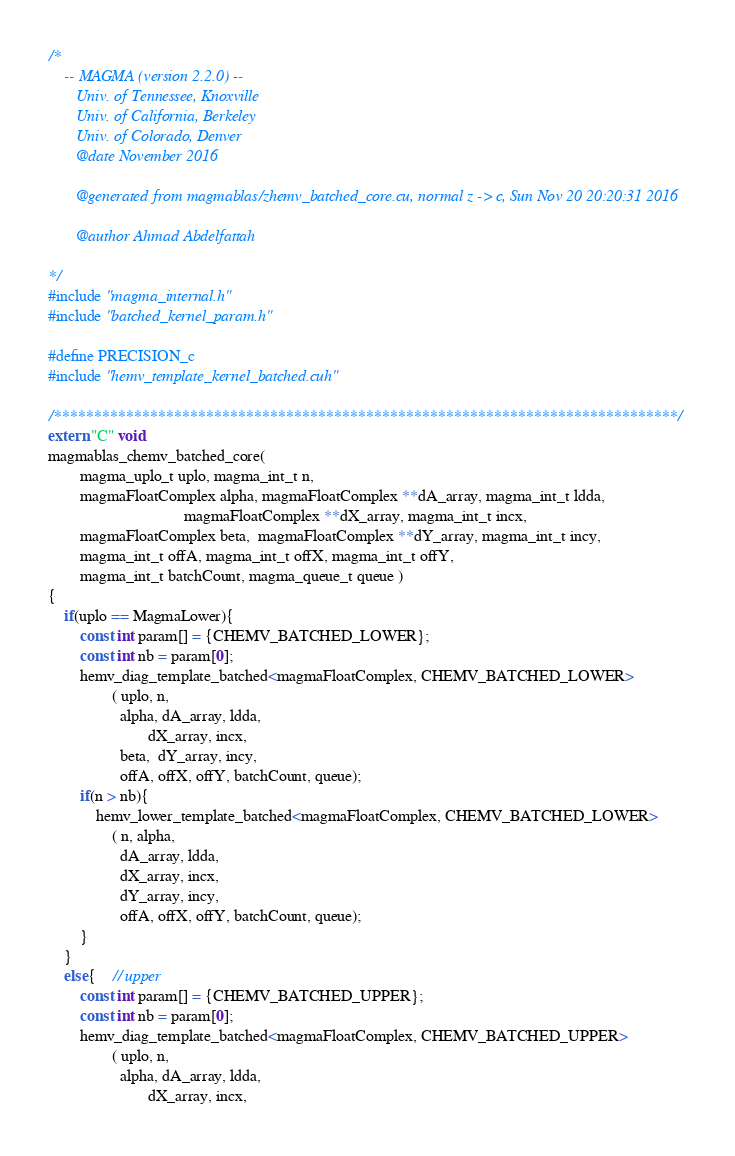Convert code to text. <code><loc_0><loc_0><loc_500><loc_500><_Cuda_>/*
    -- MAGMA (version 2.2.0) --
       Univ. of Tennessee, Knoxville
       Univ. of California, Berkeley
       Univ. of Colorado, Denver
       @date November 2016

       @generated from magmablas/zhemv_batched_core.cu, normal z -> c, Sun Nov 20 20:20:31 2016

       @author Ahmad Abdelfattah
       
*/
#include "magma_internal.h"
#include "batched_kernel_param.h"

#define PRECISION_c
#include "hemv_template_kernel_batched.cuh"

/******************************************************************************/
extern "C" void 
magmablas_chemv_batched_core(
        magma_uplo_t uplo, magma_int_t n, 
        magmaFloatComplex alpha, magmaFloatComplex **dA_array, magma_int_t ldda,
                                  magmaFloatComplex **dX_array, magma_int_t incx,
        magmaFloatComplex beta,  magmaFloatComplex **dY_array, magma_int_t incy,
        magma_int_t offA, magma_int_t offX, magma_int_t offY, 
        magma_int_t batchCount, magma_queue_t queue )
{
    if(uplo == MagmaLower){
        const int param[] = {CHEMV_BATCHED_LOWER};
        const int nb = param[0];
        hemv_diag_template_batched<magmaFloatComplex, CHEMV_BATCHED_LOWER>
                ( uplo, n, 
                  alpha, dA_array, ldda, 
                         dX_array, incx, 
                  beta,  dY_array, incy, 
                  offA, offX, offY, batchCount, queue);
        if(n > nb){
            hemv_lower_template_batched<magmaFloatComplex, CHEMV_BATCHED_LOWER>
                ( n, alpha, 
                  dA_array, ldda, 
                  dX_array, incx, 
                  dY_array, incy, 
                  offA, offX, offY, batchCount, queue);
        }
    }
    else{    // upper
        const int param[] = {CHEMV_BATCHED_UPPER};
        const int nb = param[0];
        hemv_diag_template_batched<magmaFloatComplex, CHEMV_BATCHED_UPPER>
                ( uplo, n, 
                  alpha, dA_array, ldda, 
                         dX_array, incx, </code> 